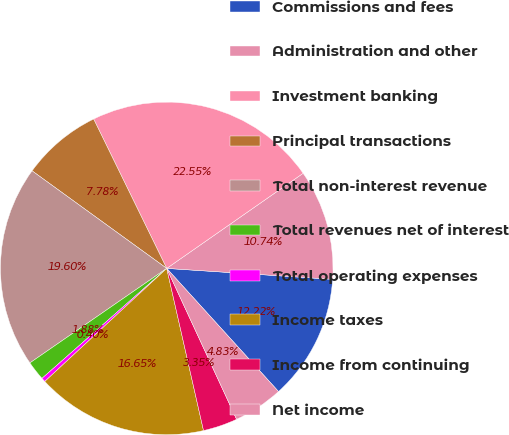<chart> <loc_0><loc_0><loc_500><loc_500><pie_chart><fcel>Commissions and fees<fcel>Administration and other<fcel>Investment banking<fcel>Principal transactions<fcel>Total non-interest revenue<fcel>Total revenues net of interest<fcel>Total operating expenses<fcel>Income taxes<fcel>Income from continuing<fcel>Net income<nl><fcel>12.22%<fcel>10.74%<fcel>22.55%<fcel>7.78%<fcel>19.6%<fcel>1.88%<fcel>0.4%<fcel>16.65%<fcel>3.35%<fcel>4.83%<nl></chart> 